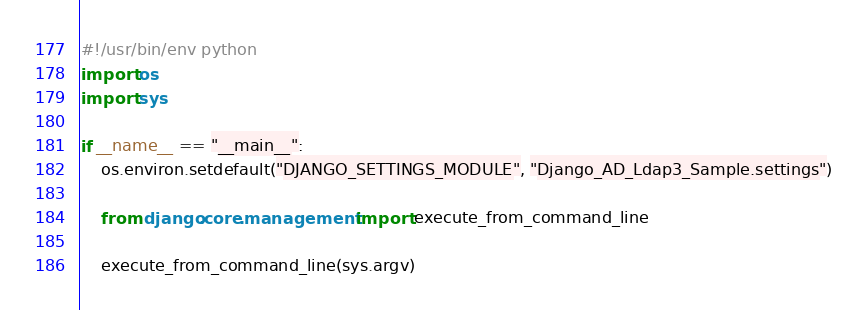Convert code to text. <code><loc_0><loc_0><loc_500><loc_500><_Python_>#!/usr/bin/env python
import os
import sys

if __name__ == "__main__":
    os.environ.setdefault("DJANGO_SETTINGS_MODULE", "Django_AD_Ldap3_Sample.settings")

    from django.core.management import execute_from_command_line

    execute_from_command_line(sys.argv)
</code> 